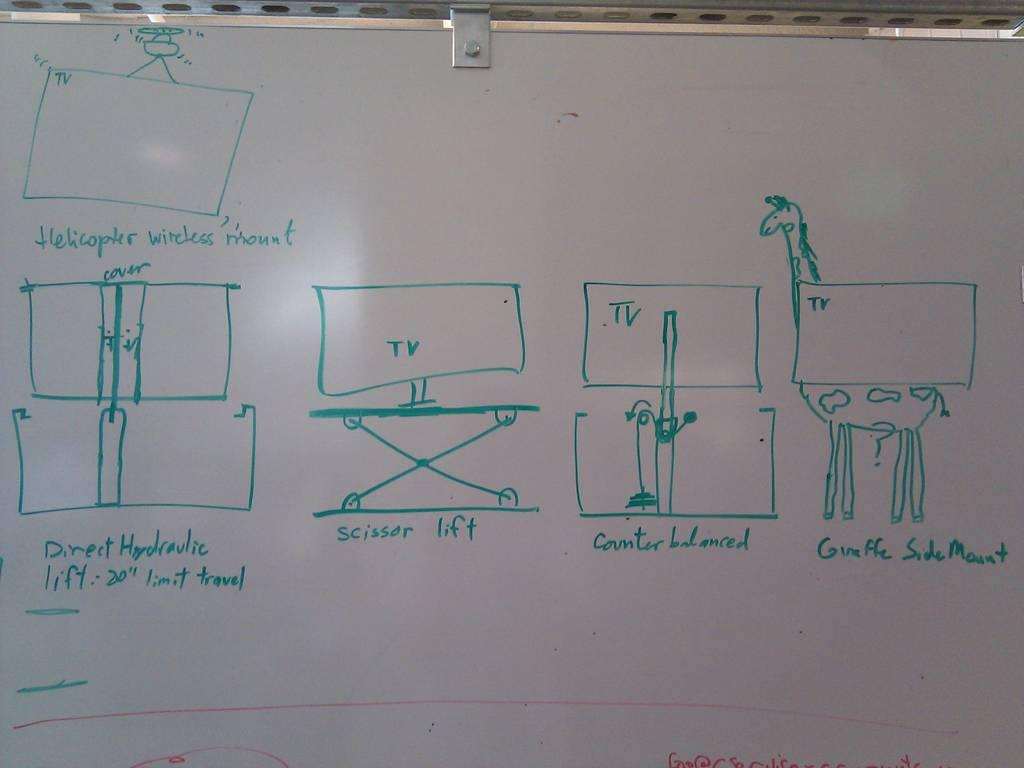Provide a one-sentence caption for the provided image. A white board has the word scissor written on it. 